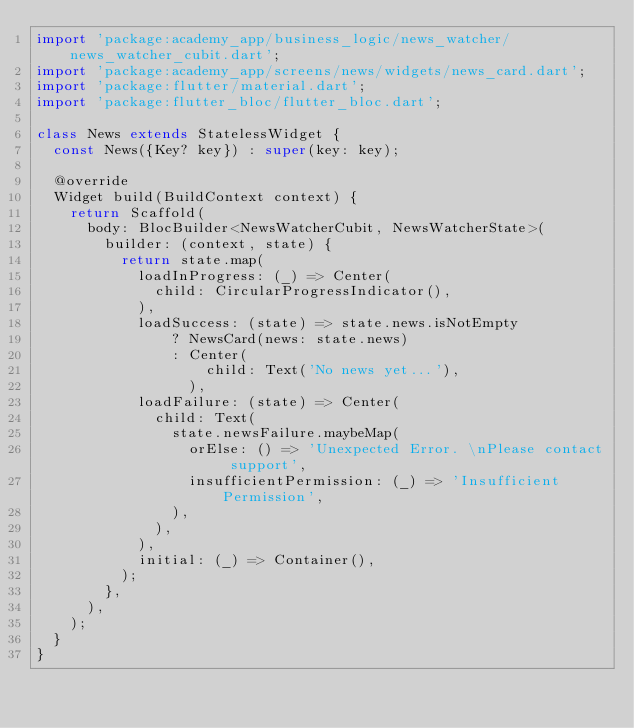Convert code to text. <code><loc_0><loc_0><loc_500><loc_500><_Dart_>import 'package:academy_app/business_logic/news_watcher/news_watcher_cubit.dart';
import 'package:academy_app/screens/news/widgets/news_card.dart';
import 'package:flutter/material.dart';
import 'package:flutter_bloc/flutter_bloc.dart';

class News extends StatelessWidget {
  const News({Key? key}) : super(key: key);

  @override
  Widget build(BuildContext context) {
    return Scaffold(
      body: BlocBuilder<NewsWatcherCubit, NewsWatcherState>(
        builder: (context, state) {
          return state.map(
            loadInProgress: (_) => Center(
              child: CircularProgressIndicator(),
            ),
            loadSuccess: (state) => state.news.isNotEmpty
                ? NewsCard(news: state.news)
                : Center(
                    child: Text('No news yet...'),
                  ),
            loadFailure: (state) => Center(
              child: Text(
                state.newsFailure.maybeMap(
                  orElse: () => 'Unexpected Error. \nPlease contact support',
                  insufficientPermission: (_) => 'Insufficient Permission',
                ),
              ),
            ),
            initial: (_) => Container(),
          );
        },
      ),
    );
  }
}
</code> 